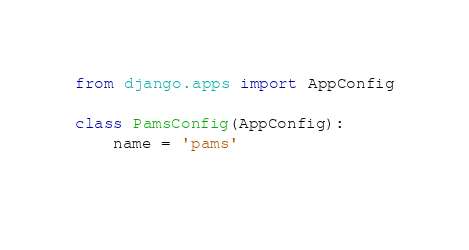<code> <loc_0><loc_0><loc_500><loc_500><_Python_>from django.apps import AppConfig

class PamsConfig(AppConfig):
    name = 'pams'
    </code> 